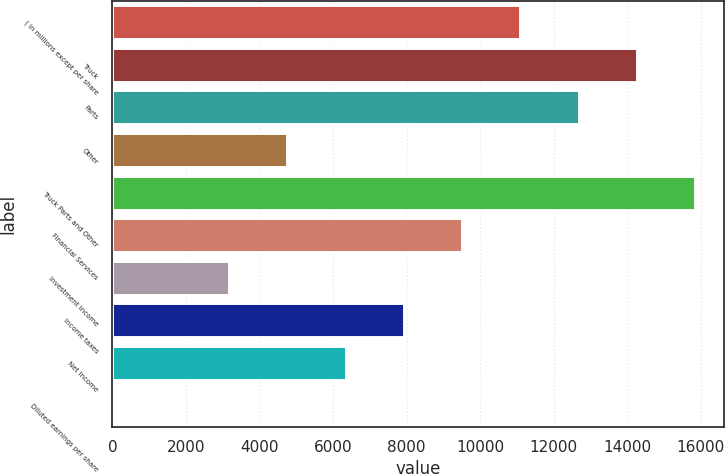Convert chart to OTSL. <chart><loc_0><loc_0><loc_500><loc_500><bar_chart><fcel>( in millions except per share<fcel>Truck<fcel>Parts<fcel>Other<fcel>Truck Parts and Other<fcel>Financial Services<fcel>Investment income<fcel>Income taxes<fcel>Net Income<fcel>Diluted earnings per share<nl><fcel>11093<fcel>14262.1<fcel>12677.6<fcel>4755.01<fcel>15846.6<fcel>9508.54<fcel>3170.5<fcel>7924.03<fcel>6339.52<fcel>1.48<nl></chart> 